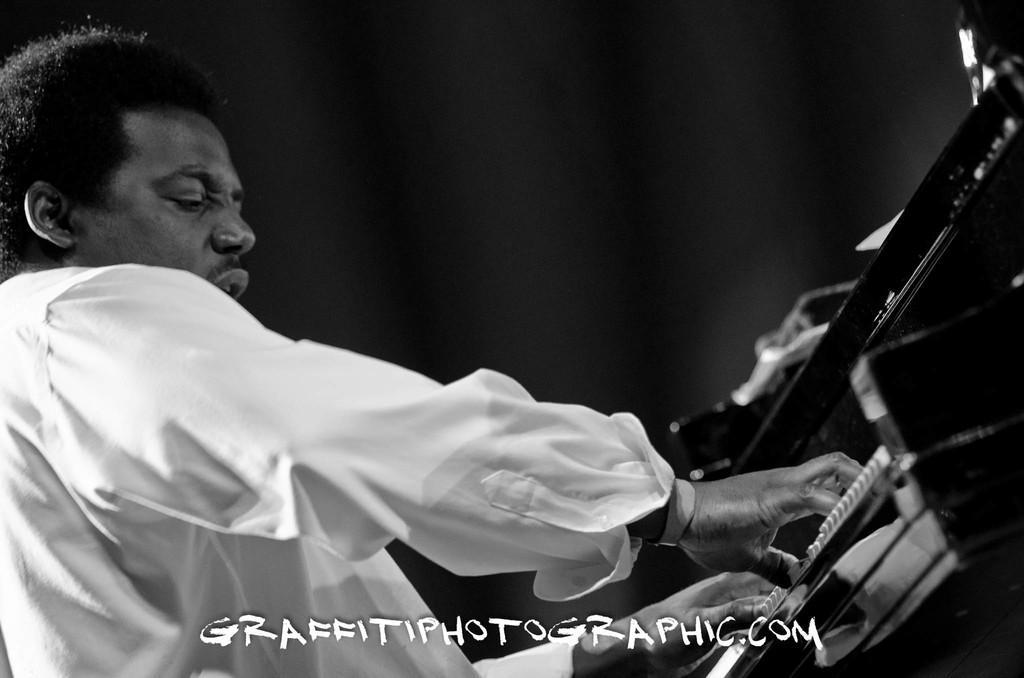How would you summarize this image in a sentence or two? In this image we can see a person playing the musical instrument, at the bottom of the image we can see some text and the background is dark. 